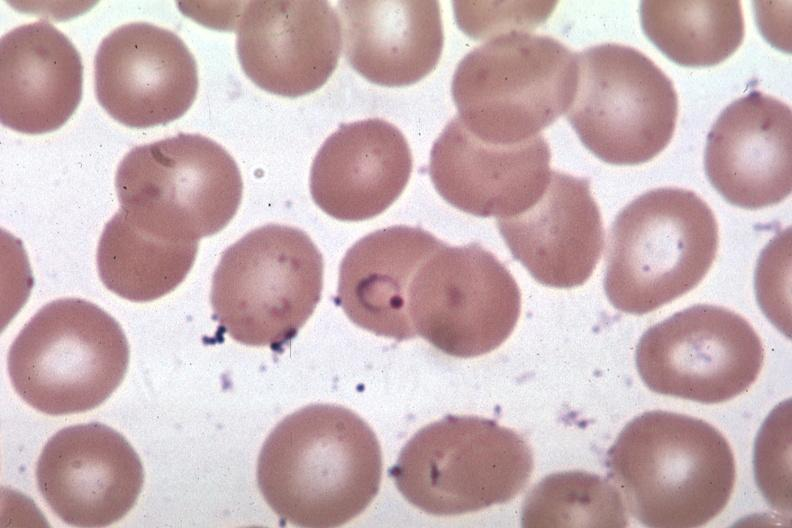s hematologic present?
Answer the question using a single word or phrase. Yes 